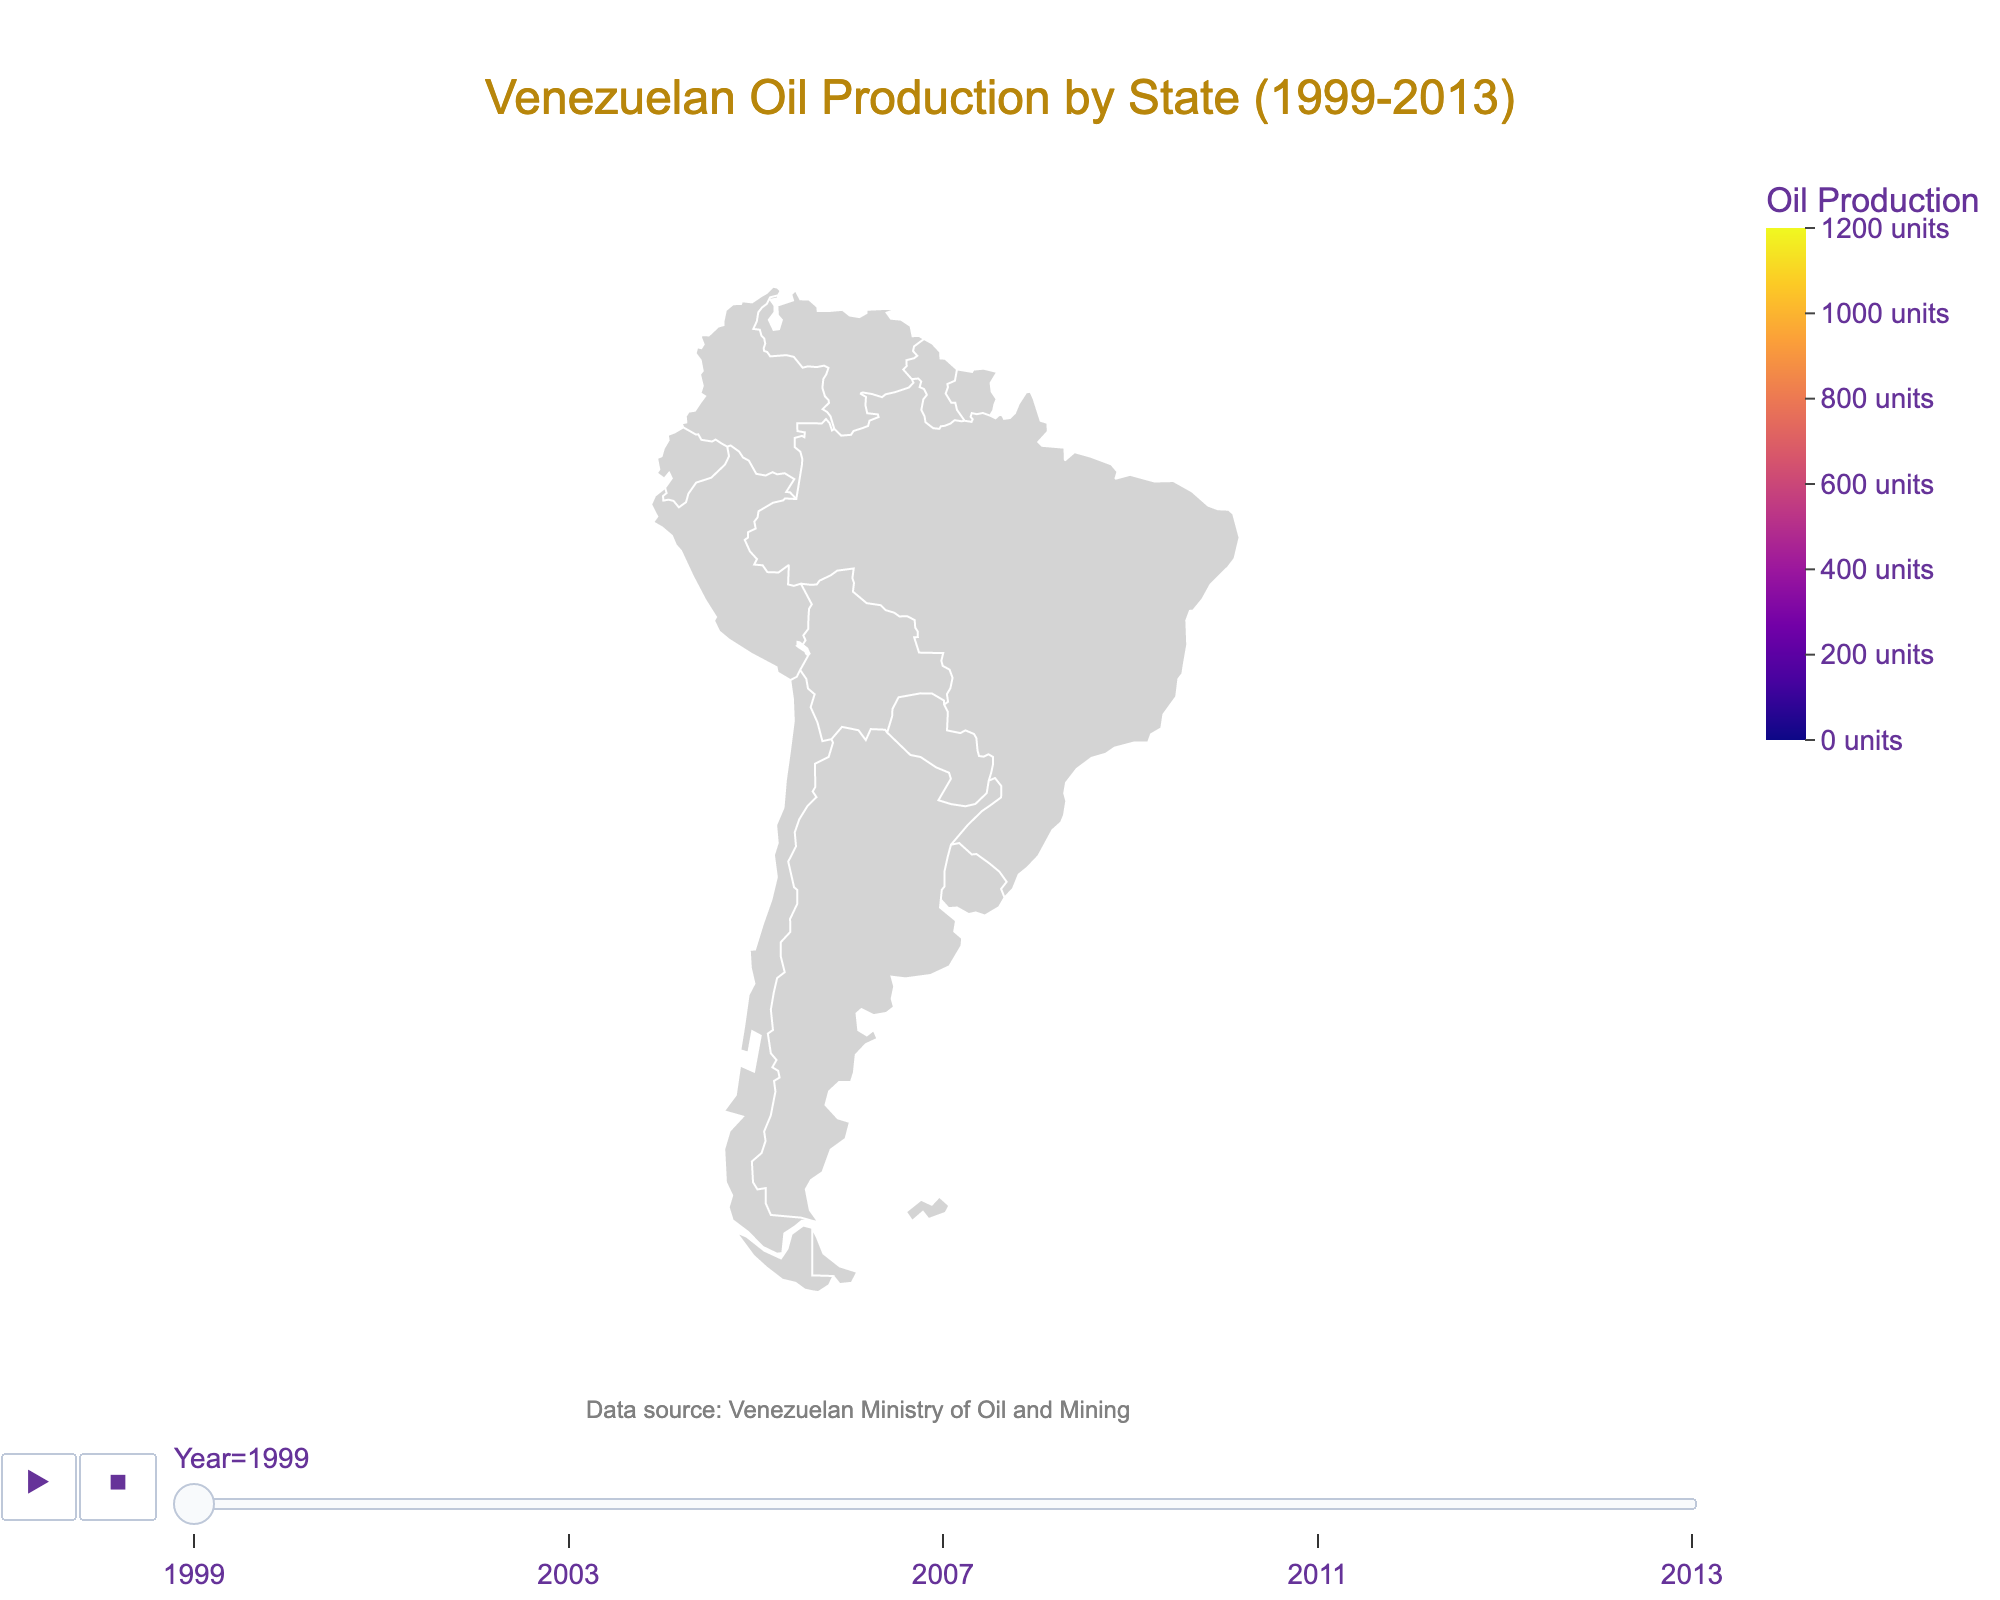Which state had the highest oil production in 1999? By examining the color representations or the specific values on the map for the year 1999, Zulia state had the highest production of 1200 units.
Answer: Zulia What is the overall trend of oil production in Apure from 1999 to 2013? Observing the color gradient or the values, you can see a consistent decrease in oil production in Apure from 150 units in 1999 to 50 units in 2013.
Answer: Decreasing How does the oil production in Monagas in 2011 compare to that in 1999? Monagas had 600 units of production in 1999, which decreased to 450 units in 2011. Therefore, there was a decrease by 150 units.
Answer: Decreased by 150 units Which state showed the greatest reduction in oil production between 1999 and 2013? To determine this, subtract the 2013 value from the 1999 value for each state and compare the reductions. Zulia had the largest reduction of 400 units (1200 - 800).
Answer: Zulia Is there any state where the oil production remained constant from start to end? Looking at the data for each state over the years, production in all states consistently decreased, indicating that none remained constant.
Answer: None What's the average oil production for Anzoátegui over the years 1999, 2003, 2007, 2011, and 2013? Sum the values for Anzoátegui over the mentioned years: (800 + 750 + 700 + 650 + 600) = 3500. Then divide by 5 to get the average, 3500 / 5 = 700.
Answer: 700 Compare the oil production in Guárico and Falcón in 2013. Which state produced more oil? Observing the values for 2013, Guárico produced 200 units while Falcón produced 150 units. Thus, Guárico produced more oil.
Answer: Guárico Which years are included in the oil production data? The title and the years marked on the animation frame indicate the data includes the years 1999, 2003, 2007, 2011, and 2013.
Answer: 1999, 2003, 2007, 2011, 2013 What's the total oil production for Barinas in the years listed? Sum up the values for Barinas over all the years: 300 + 275 + 250 + 225 + 200 = 1250 units.
Answer: 1250 units 